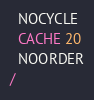Convert code to text. <code><loc_0><loc_0><loc_500><loc_500><_SQL_>  NOCYCLE
  CACHE 20
  NOORDER
/
</code> 